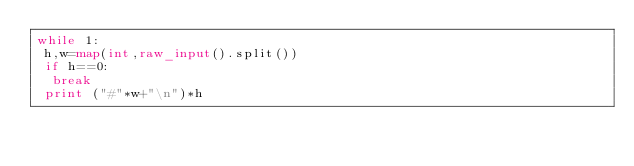<code> <loc_0><loc_0><loc_500><loc_500><_Python_>while 1:
 h,w=map(int,raw_input().split())
 if h==0:
  break
 print ("#"*w+"\n")*h</code> 